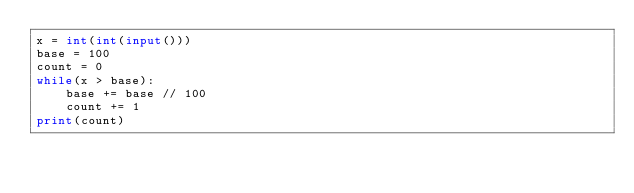Convert code to text. <code><loc_0><loc_0><loc_500><loc_500><_Python_>x = int(int(input()))
base = 100
count = 0
while(x > base):
    base += base // 100
    count += 1
print(count)
</code> 